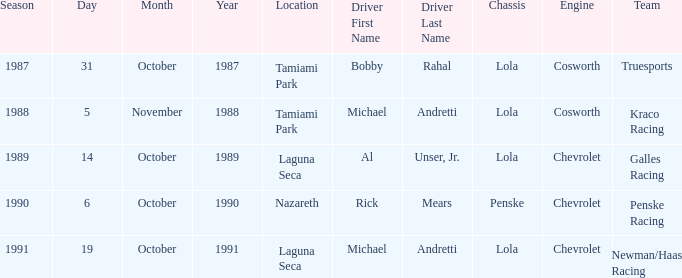Which team raced on October 19? Newman/Haas Racing. 